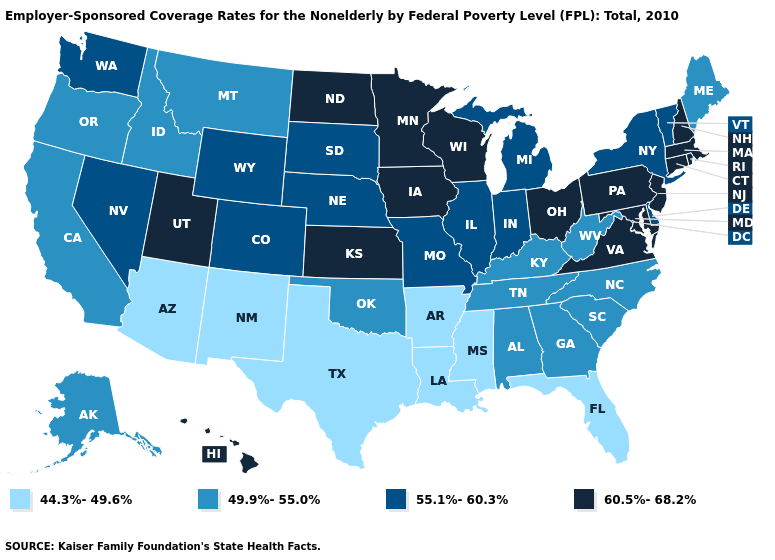Does Indiana have a higher value than Iowa?
Quick response, please. No. What is the highest value in states that border California?
Write a very short answer. 55.1%-60.3%. Name the states that have a value in the range 44.3%-49.6%?
Be succinct. Arizona, Arkansas, Florida, Louisiana, Mississippi, New Mexico, Texas. What is the value of Montana?
Keep it brief. 49.9%-55.0%. What is the lowest value in the Northeast?
Concise answer only. 49.9%-55.0%. Among the states that border South Dakota , does Iowa have the highest value?
Write a very short answer. Yes. Name the states that have a value in the range 44.3%-49.6%?
Short answer required. Arizona, Arkansas, Florida, Louisiana, Mississippi, New Mexico, Texas. Which states hav the highest value in the South?
Answer briefly. Maryland, Virginia. Name the states that have a value in the range 55.1%-60.3%?
Answer briefly. Colorado, Delaware, Illinois, Indiana, Michigan, Missouri, Nebraska, Nevada, New York, South Dakota, Vermont, Washington, Wyoming. Does the first symbol in the legend represent the smallest category?
Answer briefly. Yes. Name the states that have a value in the range 49.9%-55.0%?
Concise answer only. Alabama, Alaska, California, Georgia, Idaho, Kentucky, Maine, Montana, North Carolina, Oklahoma, Oregon, South Carolina, Tennessee, West Virginia. What is the value of Wisconsin?
Concise answer only. 60.5%-68.2%. What is the value of North Dakota?
Answer briefly. 60.5%-68.2%. Which states have the lowest value in the MidWest?
Write a very short answer. Illinois, Indiana, Michigan, Missouri, Nebraska, South Dakota. Which states hav the highest value in the South?
Keep it brief. Maryland, Virginia. 